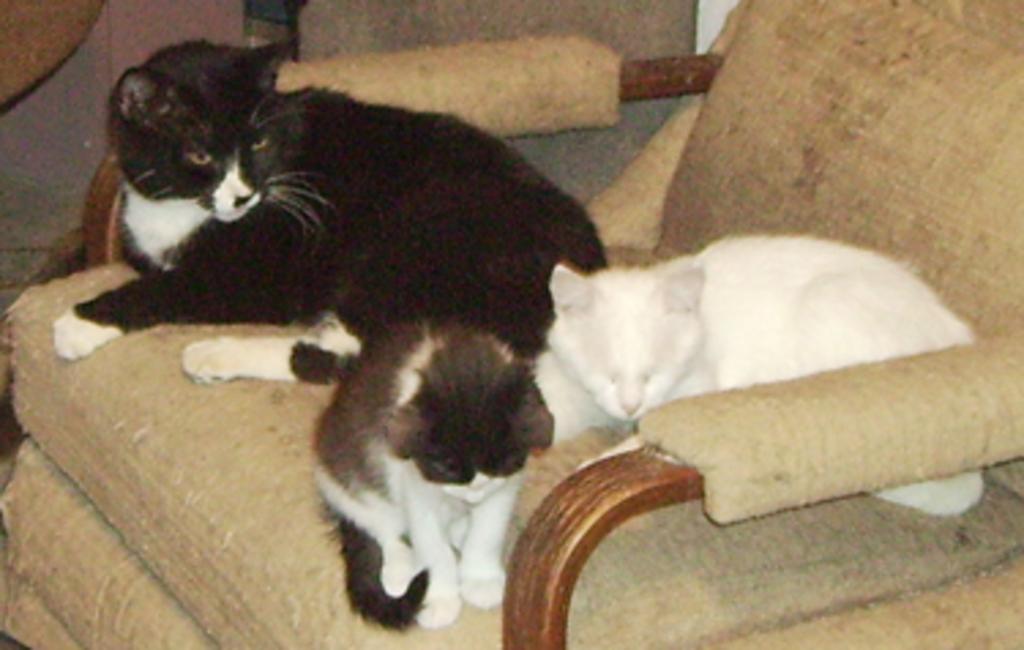Describe this image in one or two sentences. As we can see in the image there is sofa. On sofa there is one white color cat and two black color cats. 